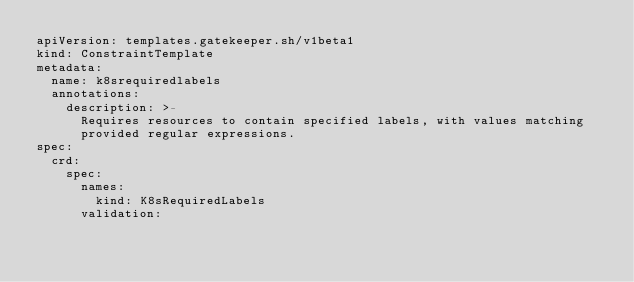Convert code to text. <code><loc_0><loc_0><loc_500><loc_500><_YAML_>apiVersion: templates.gatekeeper.sh/v1beta1
kind: ConstraintTemplate
metadata:
  name: k8srequiredlabels
  annotations:
    description: >-
      Requires resources to contain specified labels, with values matching
      provided regular expressions.
spec:
  crd:
    spec:
      names:
        kind: K8sRequiredLabels
      validation:</code> 